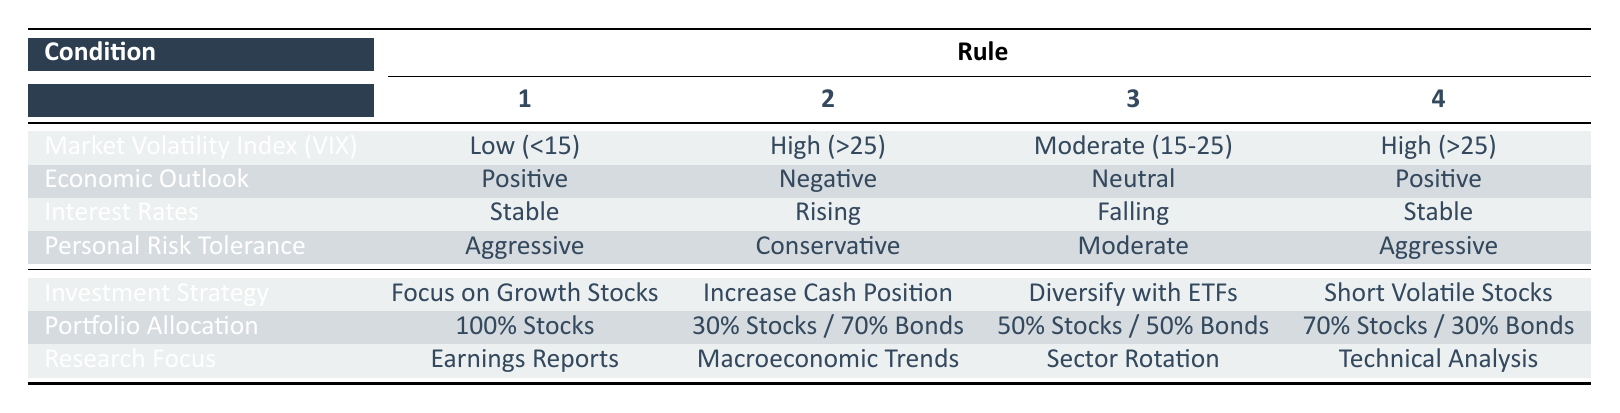What investment strategy is recommended when market volatility is high, the economic outlook is negative, interest rates are rising, and personal risk tolerance is conservative? According to the table, the specified combination of conditions shows that the recommended investment strategy is to "Increase Cash Position."
Answer: Increase Cash Position What portfolio allocation is suggested when market volatility is low, the economic outlook is positive, interest rates are stable, and personal risk tolerance is aggressive? The table indicates that for these conditions, the portfolio allocation should be "100% Stocks."
Answer: 100% Stocks Is it true that diversifying with ETFs is recommended when the economic outlook is neutral? The table shows that "Diversify with ETFs" is the action taken under the condition of a neutral economic outlook and moderate personal risk tolerance, confirming that it is true.
Answer: Yes Which research focus is associated with a high market volatility index, a positive economic outlook, stable interest rates, and aggressive personal risk tolerance? The table shows that under these conditions, the research focus recommended is "Technical Analysis."
Answer: Technical Analysis What is the portfolio allocation when investing in defensive sectors with falling interest rates and negative economic outlook? From the table, the portfolio allocation associated with these conditions (low VIX, negative economic outlook, falling interest rates, conservative risk tolerance) is "50% Stocks / 30% Bonds / 20% Cash."
Answer: 50% Stocks / 30% Bonds / 20% Cash When the market volatility index is moderate and the economic outlook is neutral, what is the investment strategy? The investment strategy for moderate volatility and neutral economic outlook, according to the table, is to "Diversify with ETFs."
Answer: Diversify with ETFs What investment strategy should be adopted if interest rates are falling, and personal risk tolerance is aggressive, regardless of other conditions? The table does not provide a specific investment strategy under just those two conditions, as it lists interactions with other variables necessary to form a strategy. Therefore, it cannot be determined.
Answer: No specific strategy Is "Focus on Growth Stocks" recommended for a scenario with high market volatility, positive economic outlook, stable interest rates, and aggressive risk tolerance? According to the table, "Focus on Growth Stocks" is the action for low VIX, positive economic outlook, stable interest rates, and aggressive risk tolerance, making it false for high VIX.
Answer: No What action is recommended if the market volatility index is high and personal risk tolerance is moderate? The table does not specify an action based solely on high market volatility index and moderate risk tolerance, as these conditions need to be combined with the economic outlook and interest rates for a specific action.
Answer: No specific action 